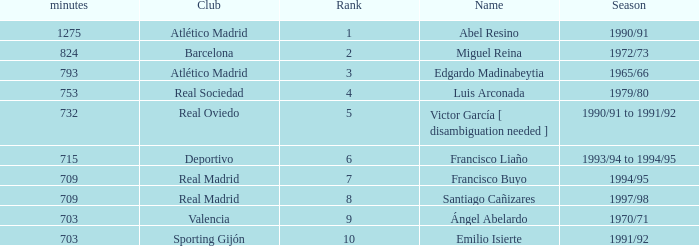What are the minutes of the Player from Real Madrid Club with a Rank of 7 or larger? 709.0. 